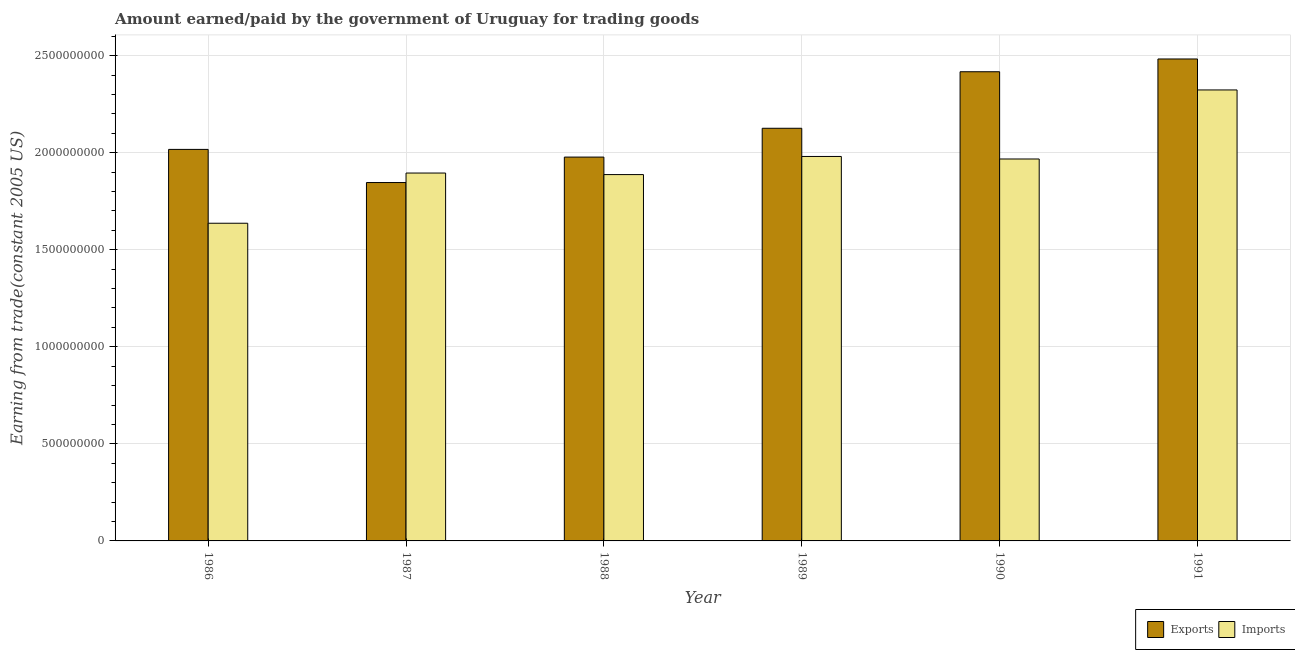Are the number of bars per tick equal to the number of legend labels?
Give a very brief answer. Yes. What is the label of the 6th group of bars from the left?
Your response must be concise. 1991. In how many cases, is the number of bars for a given year not equal to the number of legend labels?
Give a very brief answer. 0. What is the amount earned from exports in 1987?
Make the answer very short. 1.85e+09. Across all years, what is the maximum amount earned from exports?
Your answer should be very brief. 2.48e+09. Across all years, what is the minimum amount paid for imports?
Your answer should be very brief. 1.64e+09. In which year was the amount paid for imports minimum?
Your response must be concise. 1986. What is the total amount earned from exports in the graph?
Make the answer very short. 1.29e+1. What is the difference between the amount earned from exports in 1988 and that in 1991?
Offer a very short reply. -5.05e+08. What is the difference between the amount paid for imports in 1986 and the amount earned from exports in 1991?
Offer a terse response. -6.87e+08. What is the average amount earned from exports per year?
Your answer should be very brief. 2.14e+09. In the year 1990, what is the difference between the amount earned from exports and amount paid for imports?
Give a very brief answer. 0. In how many years, is the amount paid for imports greater than 1300000000 US$?
Keep it short and to the point. 6. What is the ratio of the amount paid for imports in 1988 to that in 1990?
Your response must be concise. 0.96. Is the amount earned from exports in 1988 less than that in 1989?
Your response must be concise. Yes. Is the difference between the amount paid for imports in 1986 and 1987 greater than the difference between the amount earned from exports in 1986 and 1987?
Ensure brevity in your answer.  No. What is the difference between the highest and the second highest amount paid for imports?
Ensure brevity in your answer.  3.43e+08. What is the difference between the highest and the lowest amount paid for imports?
Make the answer very short. 6.87e+08. In how many years, is the amount earned from exports greater than the average amount earned from exports taken over all years?
Give a very brief answer. 2. What does the 1st bar from the left in 1991 represents?
Give a very brief answer. Exports. What does the 1st bar from the right in 1987 represents?
Offer a very short reply. Imports. Are all the bars in the graph horizontal?
Give a very brief answer. No. How many years are there in the graph?
Provide a succinct answer. 6. What is the difference between two consecutive major ticks on the Y-axis?
Offer a terse response. 5.00e+08. Are the values on the major ticks of Y-axis written in scientific E-notation?
Ensure brevity in your answer.  No. Does the graph contain grids?
Make the answer very short. Yes. Where does the legend appear in the graph?
Offer a terse response. Bottom right. How many legend labels are there?
Ensure brevity in your answer.  2. What is the title of the graph?
Keep it short and to the point. Amount earned/paid by the government of Uruguay for trading goods. What is the label or title of the X-axis?
Your answer should be compact. Year. What is the label or title of the Y-axis?
Make the answer very short. Earning from trade(constant 2005 US). What is the Earning from trade(constant 2005 US) in Exports in 1986?
Make the answer very short. 2.02e+09. What is the Earning from trade(constant 2005 US) of Imports in 1986?
Provide a short and direct response. 1.64e+09. What is the Earning from trade(constant 2005 US) of Exports in 1987?
Give a very brief answer. 1.85e+09. What is the Earning from trade(constant 2005 US) in Imports in 1987?
Give a very brief answer. 1.89e+09. What is the Earning from trade(constant 2005 US) in Exports in 1988?
Your answer should be very brief. 1.98e+09. What is the Earning from trade(constant 2005 US) of Imports in 1988?
Offer a terse response. 1.89e+09. What is the Earning from trade(constant 2005 US) of Exports in 1989?
Make the answer very short. 2.13e+09. What is the Earning from trade(constant 2005 US) in Imports in 1989?
Your answer should be compact. 1.98e+09. What is the Earning from trade(constant 2005 US) in Exports in 1990?
Offer a terse response. 2.42e+09. What is the Earning from trade(constant 2005 US) of Imports in 1990?
Your answer should be compact. 1.97e+09. What is the Earning from trade(constant 2005 US) of Exports in 1991?
Give a very brief answer. 2.48e+09. What is the Earning from trade(constant 2005 US) of Imports in 1991?
Offer a terse response. 2.32e+09. Across all years, what is the maximum Earning from trade(constant 2005 US) in Exports?
Ensure brevity in your answer.  2.48e+09. Across all years, what is the maximum Earning from trade(constant 2005 US) of Imports?
Offer a very short reply. 2.32e+09. Across all years, what is the minimum Earning from trade(constant 2005 US) in Exports?
Provide a short and direct response. 1.85e+09. Across all years, what is the minimum Earning from trade(constant 2005 US) in Imports?
Your answer should be compact. 1.64e+09. What is the total Earning from trade(constant 2005 US) in Exports in the graph?
Give a very brief answer. 1.29e+1. What is the total Earning from trade(constant 2005 US) of Imports in the graph?
Make the answer very short. 1.17e+1. What is the difference between the Earning from trade(constant 2005 US) in Exports in 1986 and that in 1987?
Offer a terse response. 1.71e+08. What is the difference between the Earning from trade(constant 2005 US) in Imports in 1986 and that in 1987?
Your answer should be very brief. -2.59e+08. What is the difference between the Earning from trade(constant 2005 US) of Exports in 1986 and that in 1988?
Ensure brevity in your answer.  3.96e+07. What is the difference between the Earning from trade(constant 2005 US) of Imports in 1986 and that in 1988?
Your answer should be very brief. -2.51e+08. What is the difference between the Earning from trade(constant 2005 US) of Exports in 1986 and that in 1989?
Make the answer very short. -1.09e+08. What is the difference between the Earning from trade(constant 2005 US) in Imports in 1986 and that in 1989?
Provide a short and direct response. -3.44e+08. What is the difference between the Earning from trade(constant 2005 US) in Exports in 1986 and that in 1990?
Offer a terse response. -4.00e+08. What is the difference between the Earning from trade(constant 2005 US) of Imports in 1986 and that in 1990?
Provide a short and direct response. -3.31e+08. What is the difference between the Earning from trade(constant 2005 US) in Exports in 1986 and that in 1991?
Give a very brief answer. -4.66e+08. What is the difference between the Earning from trade(constant 2005 US) of Imports in 1986 and that in 1991?
Offer a very short reply. -6.87e+08. What is the difference between the Earning from trade(constant 2005 US) of Exports in 1987 and that in 1988?
Your answer should be very brief. -1.31e+08. What is the difference between the Earning from trade(constant 2005 US) of Imports in 1987 and that in 1988?
Ensure brevity in your answer.  7.93e+06. What is the difference between the Earning from trade(constant 2005 US) of Exports in 1987 and that in 1989?
Keep it short and to the point. -2.80e+08. What is the difference between the Earning from trade(constant 2005 US) of Imports in 1987 and that in 1989?
Offer a terse response. -8.54e+07. What is the difference between the Earning from trade(constant 2005 US) of Exports in 1987 and that in 1990?
Your answer should be compact. -5.71e+08. What is the difference between the Earning from trade(constant 2005 US) of Imports in 1987 and that in 1990?
Your answer should be compact. -7.24e+07. What is the difference between the Earning from trade(constant 2005 US) in Exports in 1987 and that in 1991?
Make the answer very short. -6.37e+08. What is the difference between the Earning from trade(constant 2005 US) of Imports in 1987 and that in 1991?
Ensure brevity in your answer.  -4.28e+08. What is the difference between the Earning from trade(constant 2005 US) in Exports in 1988 and that in 1989?
Make the answer very short. -1.48e+08. What is the difference between the Earning from trade(constant 2005 US) of Imports in 1988 and that in 1989?
Provide a short and direct response. -9.33e+07. What is the difference between the Earning from trade(constant 2005 US) in Exports in 1988 and that in 1990?
Your response must be concise. -4.40e+08. What is the difference between the Earning from trade(constant 2005 US) of Imports in 1988 and that in 1990?
Your response must be concise. -8.03e+07. What is the difference between the Earning from trade(constant 2005 US) in Exports in 1988 and that in 1991?
Your answer should be compact. -5.05e+08. What is the difference between the Earning from trade(constant 2005 US) of Imports in 1988 and that in 1991?
Give a very brief answer. -4.36e+08. What is the difference between the Earning from trade(constant 2005 US) in Exports in 1989 and that in 1990?
Provide a short and direct response. -2.91e+08. What is the difference between the Earning from trade(constant 2005 US) in Imports in 1989 and that in 1990?
Offer a very short reply. 1.30e+07. What is the difference between the Earning from trade(constant 2005 US) of Exports in 1989 and that in 1991?
Your response must be concise. -3.57e+08. What is the difference between the Earning from trade(constant 2005 US) in Imports in 1989 and that in 1991?
Make the answer very short. -3.43e+08. What is the difference between the Earning from trade(constant 2005 US) in Exports in 1990 and that in 1991?
Your answer should be compact. -6.58e+07. What is the difference between the Earning from trade(constant 2005 US) in Imports in 1990 and that in 1991?
Keep it short and to the point. -3.56e+08. What is the difference between the Earning from trade(constant 2005 US) in Exports in 1986 and the Earning from trade(constant 2005 US) in Imports in 1987?
Offer a terse response. 1.22e+08. What is the difference between the Earning from trade(constant 2005 US) of Exports in 1986 and the Earning from trade(constant 2005 US) of Imports in 1988?
Keep it short and to the point. 1.30e+08. What is the difference between the Earning from trade(constant 2005 US) of Exports in 1986 and the Earning from trade(constant 2005 US) of Imports in 1989?
Your answer should be compact. 3.64e+07. What is the difference between the Earning from trade(constant 2005 US) in Exports in 1986 and the Earning from trade(constant 2005 US) in Imports in 1990?
Offer a very short reply. 4.94e+07. What is the difference between the Earning from trade(constant 2005 US) in Exports in 1986 and the Earning from trade(constant 2005 US) in Imports in 1991?
Offer a terse response. -3.06e+08. What is the difference between the Earning from trade(constant 2005 US) in Exports in 1987 and the Earning from trade(constant 2005 US) in Imports in 1988?
Make the answer very short. -4.10e+07. What is the difference between the Earning from trade(constant 2005 US) in Exports in 1987 and the Earning from trade(constant 2005 US) in Imports in 1989?
Ensure brevity in your answer.  -1.34e+08. What is the difference between the Earning from trade(constant 2005 US) of Exports in 1987 and the Earning from trade(constant 2005 US) of Imports in 1990?
Keep it short and to the point. -1.21e+08. What is the difference between the Earning from trade(constant 2005 US) of Exports in 1987 and the Earning from trade(constant 2005 US) of Imports in 1991?
Offer a terse response. -4.77e+08. What is the difference between the Earning from trade(constant 2005 US) in Exports in 1988 and the Earning from trade(constant 2005 US) in Imports in 1989?
Give a very brief answer. -3.20e+06. What is the difference between the Earning from trade(constant 2005 US) in Exports in 1988 and the Earning from trade(constant 2005 US) in Imports in 1990?
Provide a succinct answer. 9.82e+06. What is the difference between the Earning from trade(constant 2005 US) in Exports in 1988 and the Earning from trade(constant 2005 US) in Imports in 1991?
Offer a terse response. -3.46e+08. What is the difference between the Earning from trade(constant 2005 US) in Exports in 1989 and the Earning from trade(constant 2005 US) in Imports in 1990?
Give a very brief answer. 1.58e+08. What is the difference between the Earning from trade(constant 2005 US) of Exports in 1989 and the Earning from trade(constant 2005 US) of Imports in 1991?
Offer a terse response. -1.97e+08. What is the difference between the Earning from trade(constant 2005 US) in Exports in 1990 and the Earning from trade(constant 2005 US) in Imports in 1991?
Offer a terse response. 9.38e+07. What is the average Earning from trade(constant 2005 US) of Exports per year?
Make the answer very short. 2.14e+09. What is the average Earning from trade(constant 2005 US) in Imports per year?
Your answer should be compact. 1.95e+09. In the year 1986, what is the difference between the Earning from trade(constant 2005 US) of Exports and Earning from trade(constant 2005 US) of Imports?
Your answer should be very brief. 3.80e+08. In the year 1987, what is the difference between the Earning from trade(constant 2005 US) of Exports and Earning from trade(constant 2005 US) of Imports?
Keep it short and to the point. -4.90e+07. In the year 1988, what is the difference between the Earning from trade(constant 2005 US) of Exports and Earning from trade(constant 2005 US) of Imports?
Make the answer very short. 9.01e+07. In the year 1989, what is the difference between the Earning from trade(constant 2005 US) in Exports and Earning from trade(constant 2005 US) in Imports?
Give a very brief answer. 1.45e+08. In the year 1990, what is the difference between the Earning from trade(constant 2005 US) in Exports and Earning from trade(constant 2005 US) in Imports?
Keep it short and to the point. 4.49e+08. In the year 1991, what is the difference between the Earning from trade(constant 2005 US) in Exports and Earning from trade(constant 2005 US) in Imports?
Offer a very short reply. 1.60e+08. What is the ratio of the Earning from trade(constant 2005 US) in Exports in 1986 to that in 1987?
Your answer should be very brief. 1.09. What is the ratio of the Earning from trade(constant 2005 US) of Imports in 1986 to that in 1987?
Your answer should be compact. 0.86. What is the ratio of the Earning from trade(constant 2005 US) of Imports in 1986 to that in 1988?
Offer a very short reply. 0.87. What is the ratio of the Earning from trade(constant 2005 US) in Exports in 1986 to that in 1989?
Provide a succinct answer. 0.95. What is the ratio of the Earning from trade(constant 2005 US) of Imports in 1986 to that in 1989?
Your response must be concise. 0.83. What is the ratio of the Earning from trade(constant 2005 US) in Exports in 1986 to that in 1990?
Your answer should be compact. 0.83. What is the ratio of the Earning from trade(constant 2005 US) in Imports in 1986 to that in 1990?
Provide a succinct answer. 0.83. What is the ratio of the Earning from trade(constant 2005 US) in Exports in 1986 to that in 1991?
Your answer should be very brief. 0.81. What is the ratio of the Earning from trade(constant 2005 US) of Imports in 1986 to that in 1991?
Offer a terse response. 0.7. What is the ratio of the Earning from trade(constant 2005 US) in Exports in 1987 to that in 1988?
Ensure brevity in your answer.  0.93. What is the ratio of the Earning from trade(constant 2005 US) in Exports in 1987 to that in 1989?
Provide a short and direct response. 0.87. What is the ratio of the Earning from trade(constant 2005 US) in Imports in 1987 to that in 1989?
Keep it short and to the point. 0.96. What is the ratio of the Earning from trade(constant 2005 US) of Exports in 1987 to that in 1990?
Keep it short and to the point. 0.76. What is the ratio of the Earning from trade(constant 2005 US) in Imports in 1987 to that in 1990?
Provide a short and direct response. 0.96. What is the ratio of the Earning from trade(constant 2005 US) in Exports in 1987 to that in 1991?
Your response must be concise. 0.74. What is the ratio of the Earning from trade(constant 2005 US) of Imports in 1987 to that in 1991?
Give a very brief answer. 0.82. What is the ratio of the Earning from trade(constant 2005 US) of Exports in 1988 to that in 1989?
Make the answer very short. 0.93. What is the ratio of the Earning from trade(constant 2005 US) in Imports in 1988 to that in 1989?
Provide a succinct answer. 0.95. What is the ratio of the Earning from trade(constant 2005 US) in Exports in 1988 to that in 1990?
Your answer should be very brief. 0.82. What is the ratio of the Earning from trade(constant 2005 US) in Imports in 1988 to that in 1990?
Ensure brevity in your answer.  0.96. What is the ratio of the Earning from trade(constant 2005 US) of Exports in 1988 to that in 1991?
Provide a succinct answer. 0.8. What is the ratio of the Earning from trade(constant 2005 US) in Imports in 1988 to that in 1991?
Make the answer very short. 0.81. What is the ratio of the Earning from trade(constant 2005 US) of Exports in 1989 to that in 1990?
Make the answer very short. 0.88. What is the ratio of the Earning from trade(constant 2005 US) of Imports in 1989 to that in 1990?
Provide a succinct answer. 1.01. What is the ratio of the Earning from trade(constant 2005 US) of Exports in 1989 to that in 1991?
Keep it short and to the point. 0.86. What is the ratio of the Earning from trade(constant 2005 US) of Imports in 1989 to that in 1991?
Provide a succinct answer. 0.85. What is the ratio of the Earning from trade(constant 2005 US) in Exports in 1990 to that in 1991?
Ensure brevity in your answer.  0.97. What is the ratio of the Earning from trade(constant 2005 US) in Imports in 1990 to that in 1991?
Give a very brief answer. 0.85. What is the difference between the highest and the second highest Earning from trade(constant 2005 US) of Exports?
Ensure brevity in your answer.  6.58e+07. What is the difference between the highest and the second highest Earning from trade(constant 2005 US) of Imports?
Make the answer very short. 3.43e+08. What is the difference between the highest and the lowest Earning from trade(constant 2005 US) in Exports?
Offer a very short reply. 6.37e+08. What is the difference between the highest and the lowest Earning from trade(constant 2005 US) of Imports?
Offer a very short reply. 6.87e+08. 